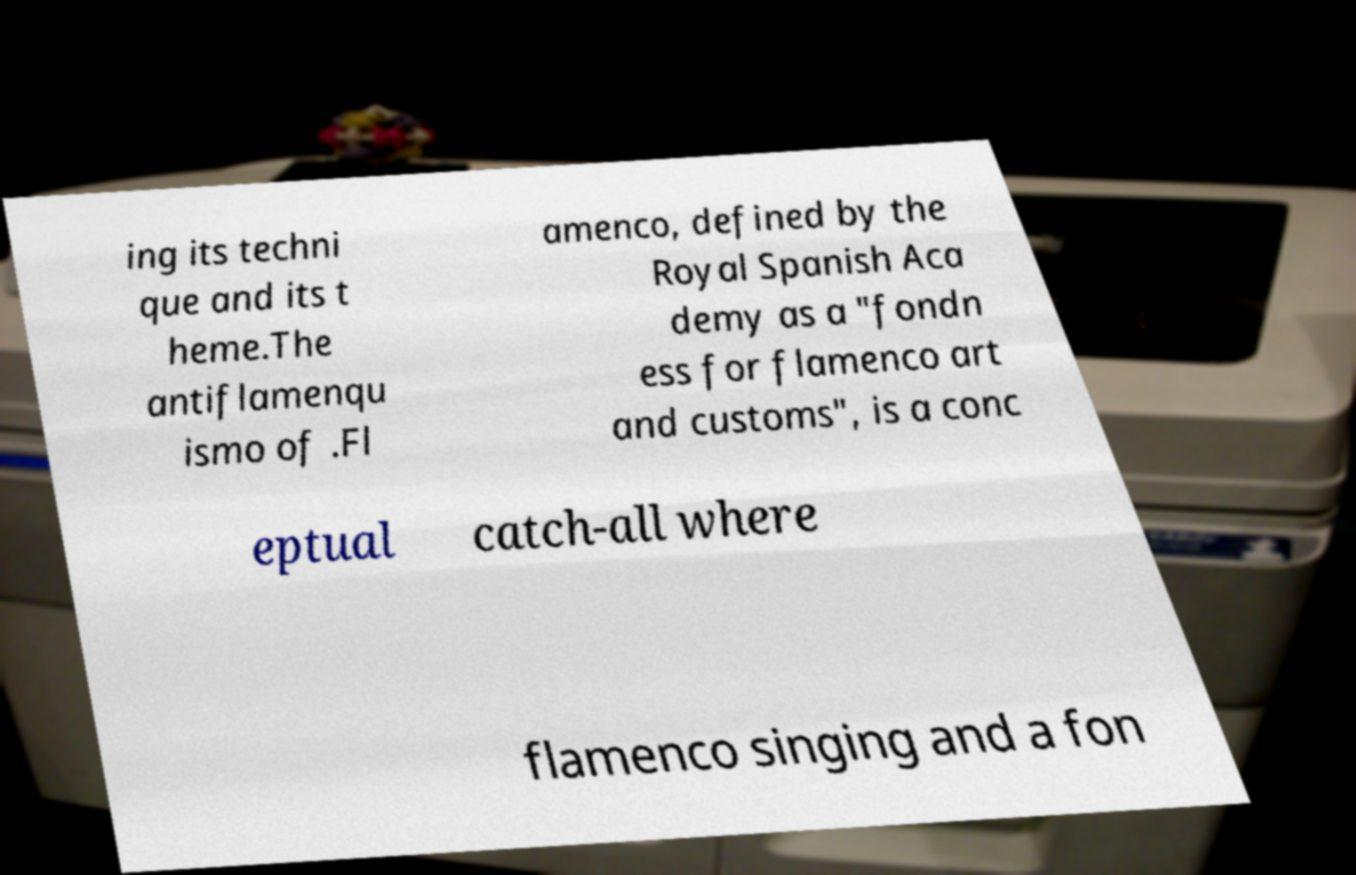What messages or text are displayed in this image? I need them in a readable, typed format. ing its techni que and its t heme.The antiflamenqu ismo of .Fl amenco, defined by the Royal Spanish Aca demy as a "fondn ess for flamenco art and customs", is a conc eptual catch-all where flamenco singing and a fon 